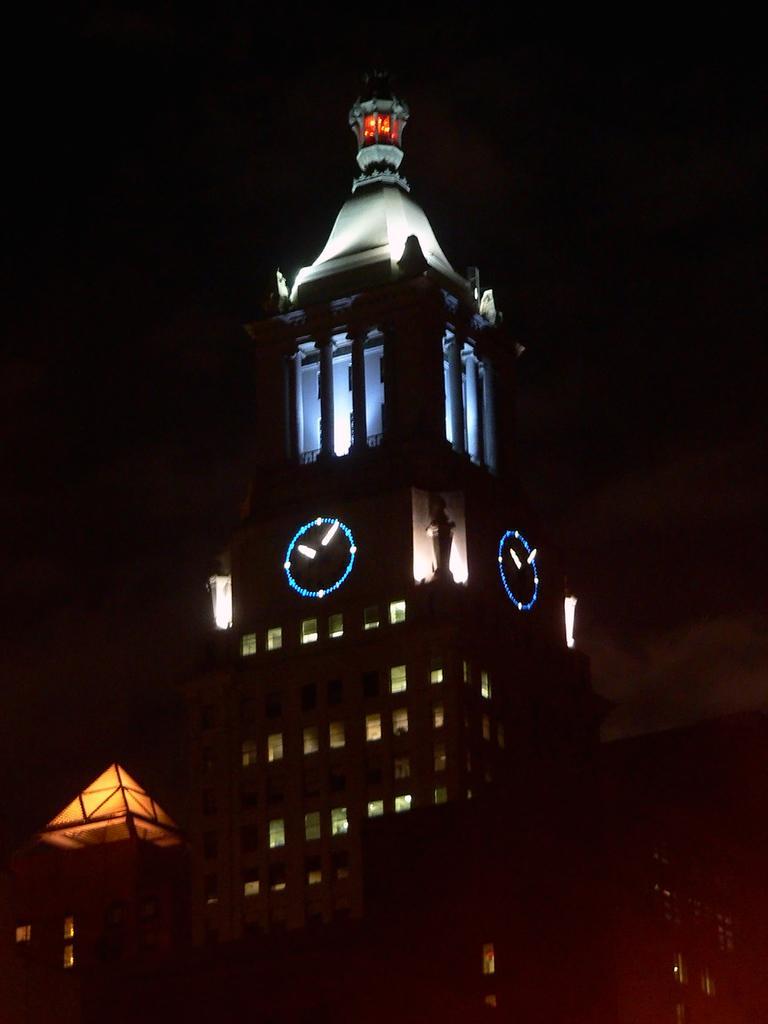In one or two sentences, can you explain what this image depicts? Here in this picture we can see a building tower present in the middle and on that we can see clocks present and we can also see lights present over there and beside that also we can see buildings present. 